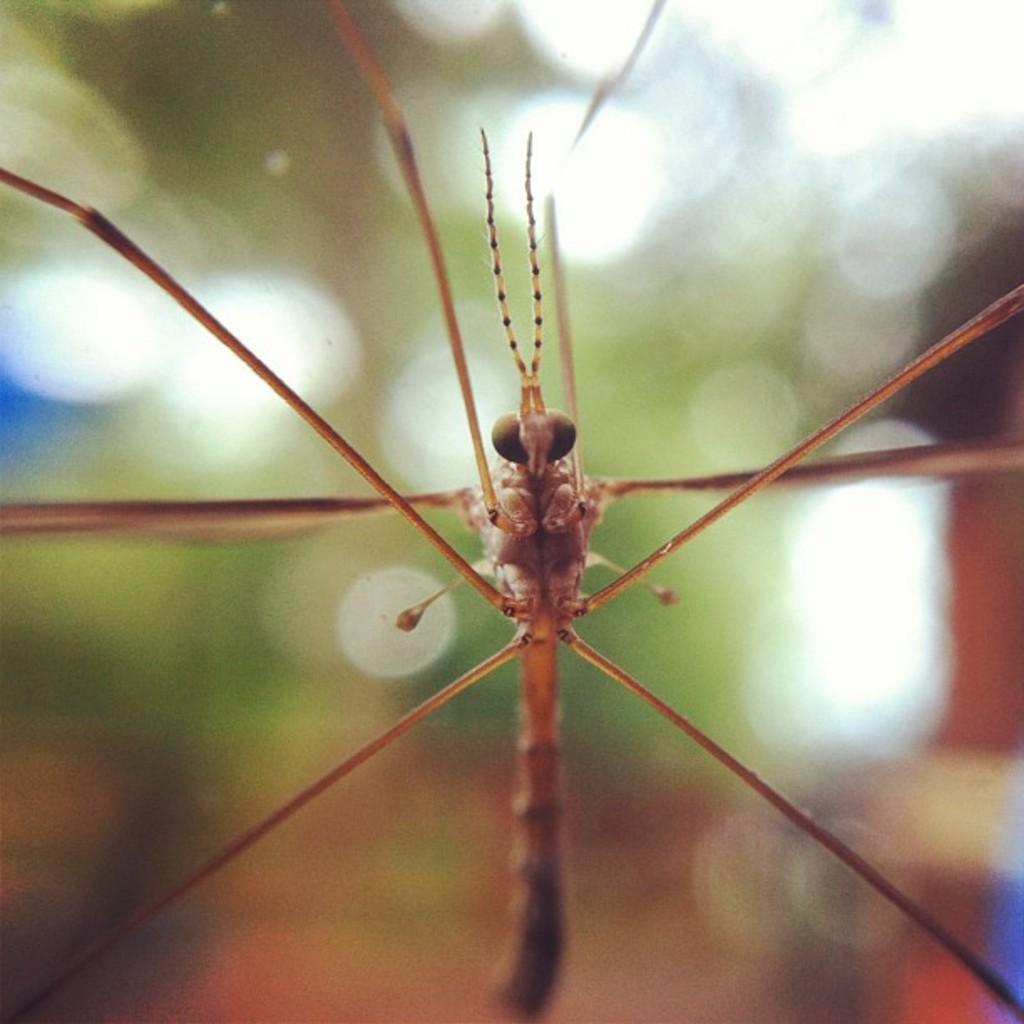Please provide a concise description of this image. In this image we can see a fly. 